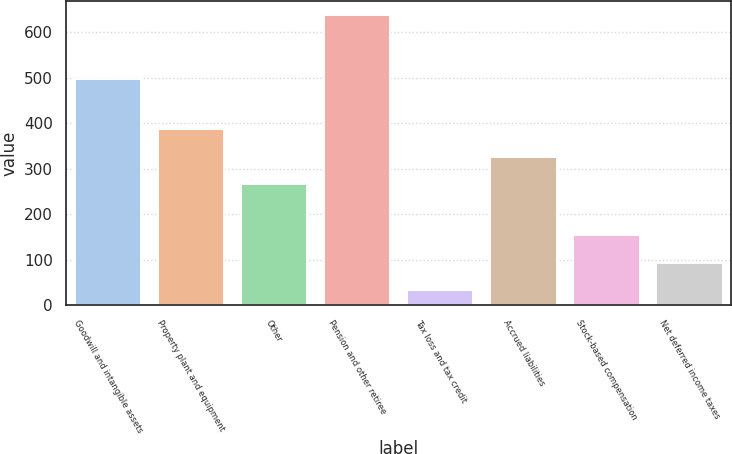Convert chart. <chart><loc_0><loc_0><loc_500><loc_500><bar_chart><fcel>Goodwill and intangible assets<fcel>Property plant and equipment<fcel>Other<fcel>Pension and other retiree<fcel>Tax loss and tax credit<fcel>Accrued liabilities<fcel>Stock-based compensation<fcel>Net deferred income taxes<nl><fcel>497<fcel>387<fcel>266<fcel>638<fcel>33<fcel>326.5<fcel>154<fcel>93.5<nl></chart> 